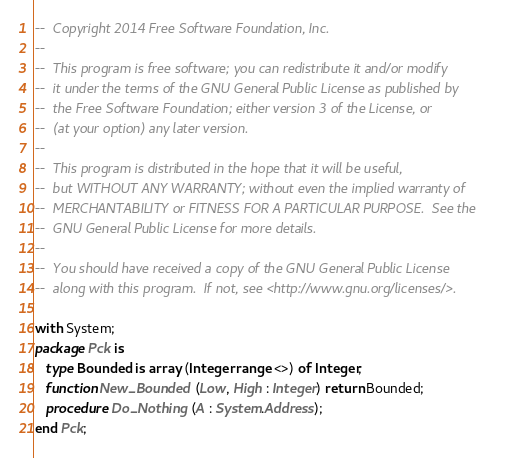<code> <loc_0><loc_0><loc_500><loc_500><_Ada_>--  Copyright 2014 Free Software Foundation, Inc.
--
--  This program is free software; you can redistribute it and/or modify
--  it under the terms of the GNU General Public License as published by
--  the Free Software Foundation; either version 3 of the License, or
--  (at your option) any later version.
--
--  This program is distributed in the hope that it will be useful,
--  but WITHOUT ANY WARRANTY; without even the implied warranty of
--  MERCHANTABILITY or FITNESS FOR A PARTICULAR PURPOSE.  See the
--  GNU General Public License for more details.
--
--  You should have received a copy of the GNU General Public License
--  along with this program.  If not, see <http://www.gnu.org/licenses/>.

with System;
package Pck is
   type Bounded is array (Integer range <>) of Integer;
   function New_Bounded (Low, High : Integer) return Bounded;
   procedure Do_Nothing (A : System.Address);
end Pck;
</code> 